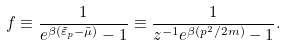<formula> <loc_0><loc_0><loc_500><loc_500>f \equiv \frac { 1 } { e ^ { \beta ( \tilde { \varepsilon } _ { p } - \tilde { \mu } ) } - 1 } \equiv \frac { 1 } { z ^ { - 1 } e ^ { \beta ( p ^ { 2 } / 2 m ) } - 1 } .</formula> 